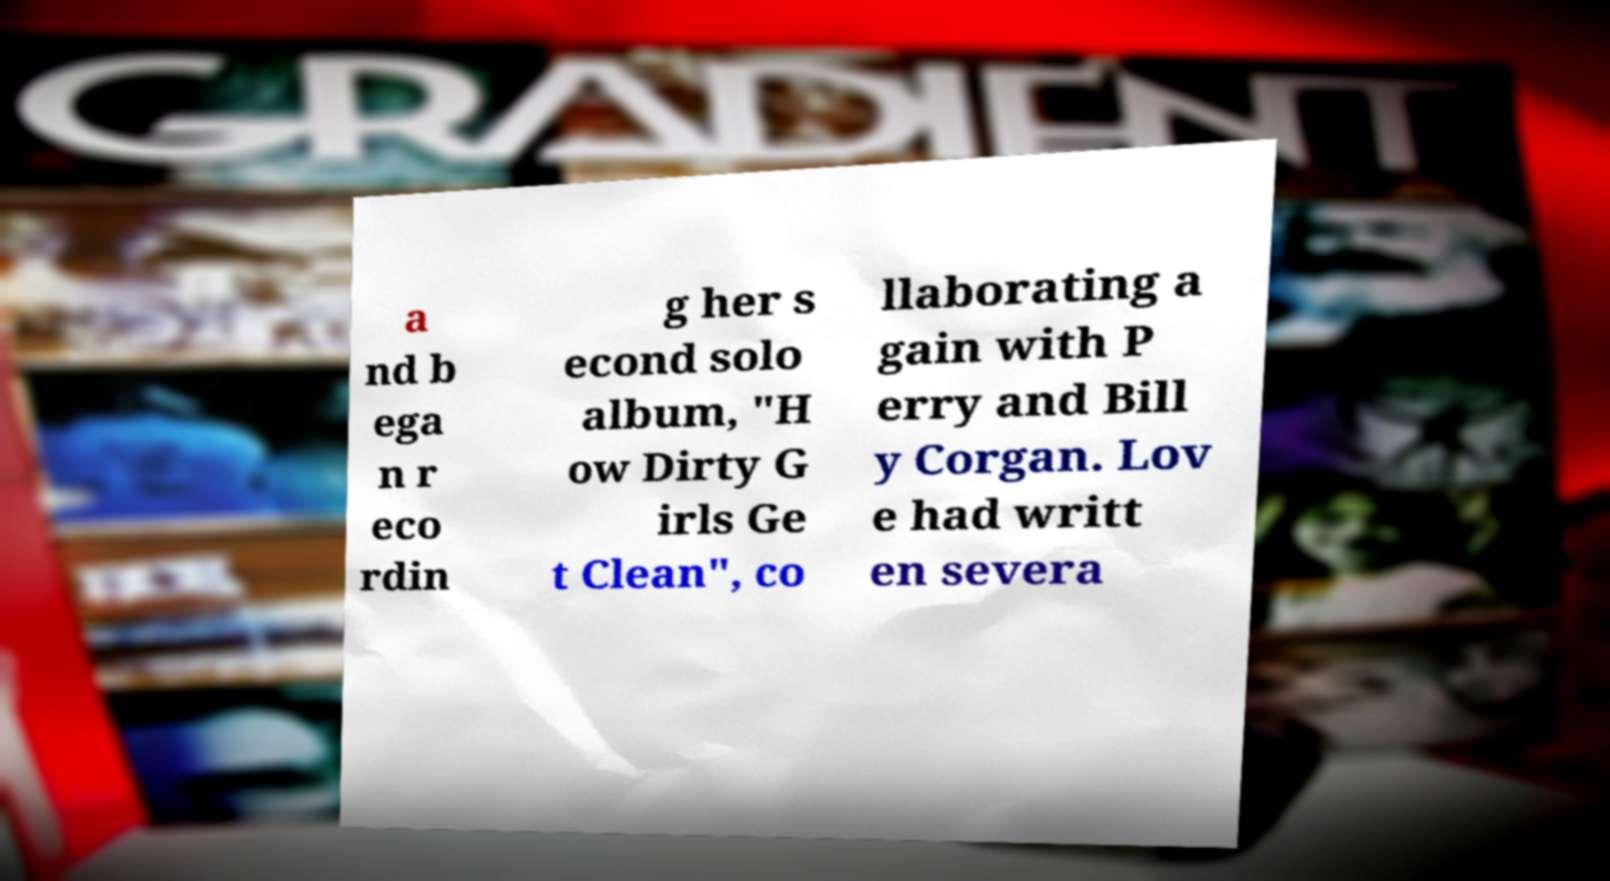Please identify and transcribe the text found in this image. a nd b ega n r eco rdin g her s econd solo album, "H ow Dirty G irls Ge t Clean", co llaborating a gain with P erry and Bill y Corgan. Lov e had writt en severa 